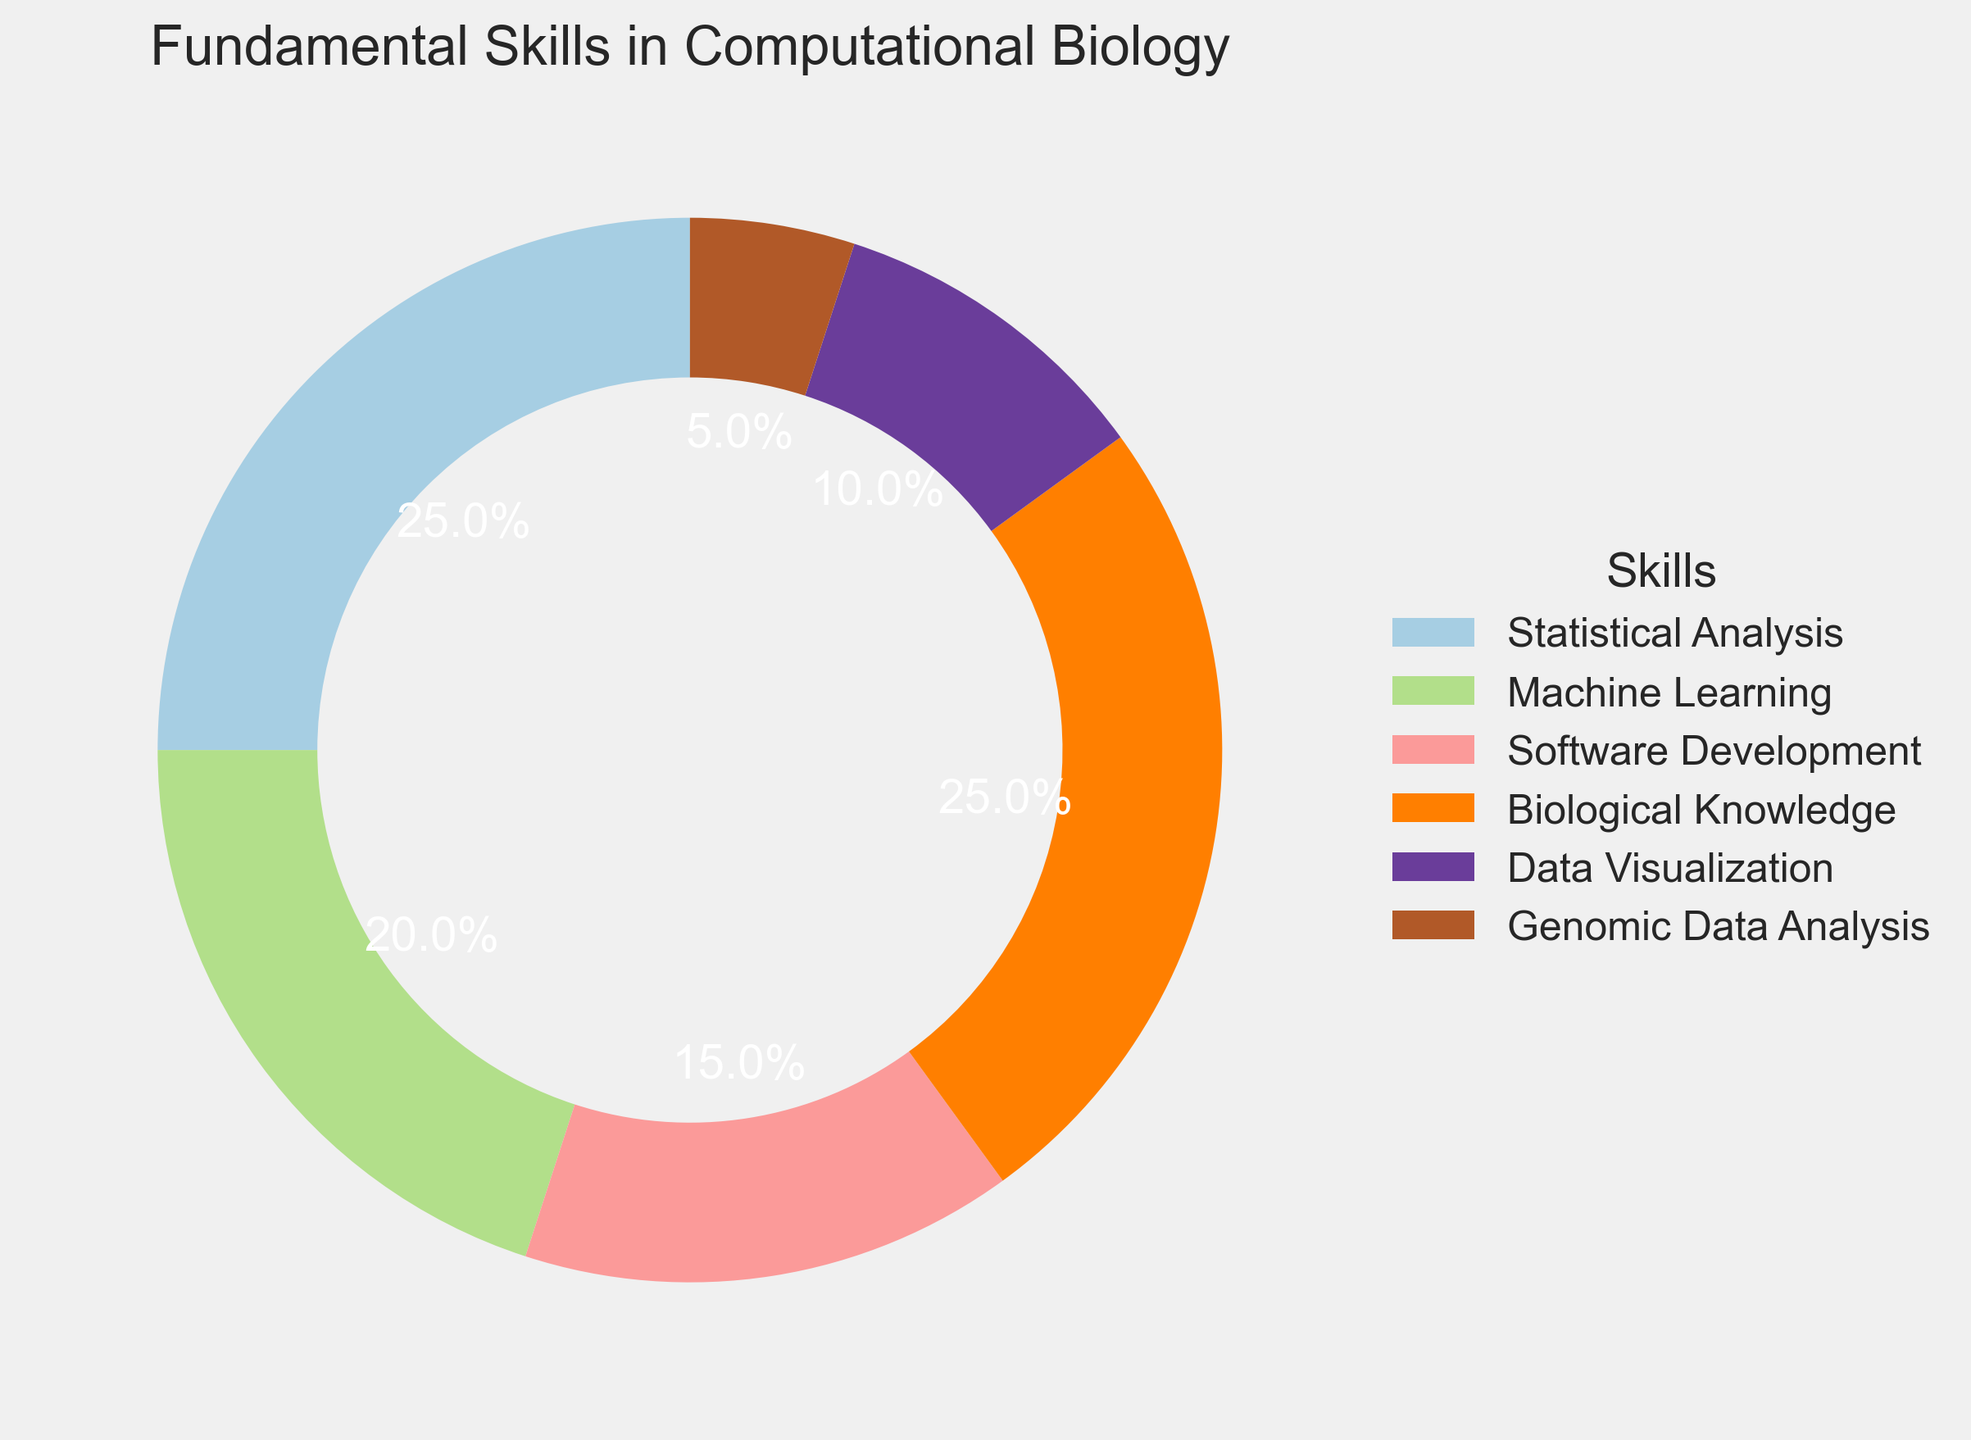What's the most common skill in computational biology according to the chart? The chart shows the percentages of different skills, and the largest sections are labeled with their respective skills and percentages. The most common skills (with the highest percentage) are Statistical Analysis and Biological Knowledge, each at 25%.
Answer: Statistical Analysis and Biological Knowledge Which skill has the smallest percentage? By observing the pie chart, we can identify the section with the smallest slice. The skill with the smallest percentage is Genomic Data Analysis at 5%.
Answer: Genomic Data Analysis How do the combined percentages of Statistical Analysis and Machine Learning compare to the combined percentages of Software Development and Data Visualization? The percentages for Statistical Analysis and Machine Learning are 25% and 20%, respectively, summing up to 45%. The percentages for Software Development and Data Visualization are 15% and 10%, respectively, summing up to 25%. 45% - 25% = 20%.
Answer: 20% If Biological Knowledge increased by 10%, what would its new percentage be? Biological Knowledge currently has a percentage of 25%. Increasing this by 10% would result in 25% + 10% = 35%.
Answer: 35% Which two skills together form the exact half of the chart's total percentage? Each skill's percentage is shown in the pie chart. Adding the percentages of Statistical Analysis (25%) and Biological Knowledge (25%) gives us 50%, which is half of the total chart.
Answer: Statistical Analysis and Biological Knowledge Is Software Development representing a larger, smaller, or equal percentage compared to Data Visualization and Genomic Data Analysis combined? Software Development has a percentage of 15%. Data Visualization and Genomic Data Analysis have percentages of 10% and 5%, respectively, summing to 15%. Hence, Software Development is equal to the combined percentage of Data Visualization and Genomic Data Analysis.
Answer: Equal What is the average percentage of all the skills represented? The total sum of the percentages of all skills is (25% + 20% + 15% + 25% + 10% + 5%) = 100%. There are 6 skills. The average percentage is 100% / 6 = 16.67%.
Answer: 16.67% What percentage difference is there between the top two largest skills and the smallest one? The two largest skills, Statistical Analysis and Biological Knowledge, each have a percentage of 25%. The smallest skill, Genomic Data Analysis, has a percentage of 5%. The difference for each of the top skills versus the smallest one is 25% - 5% = 20%.
Answer: 20% If Machine Learning and Data Visualization were combined into a single skill, what would be the new percentage for this combined skill? Machine Learning has a percentage of 20%, and Data Visualization has a percentage of 10%. Combined, they would sum up to 20% + 10% = 30%.
Answer: 30% 